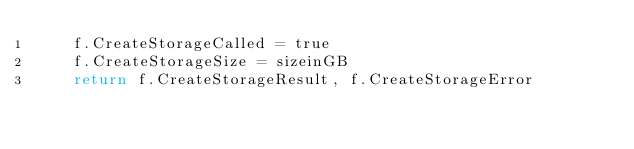<code> <loc_0><loc_0><loc_500><loc_500><_Go_>	f.CreateStorageCalled = true
	f.CreateStorageSize = sizeinGB
	return f.CreateStorageResult, f.CreateStorageError
</code> 